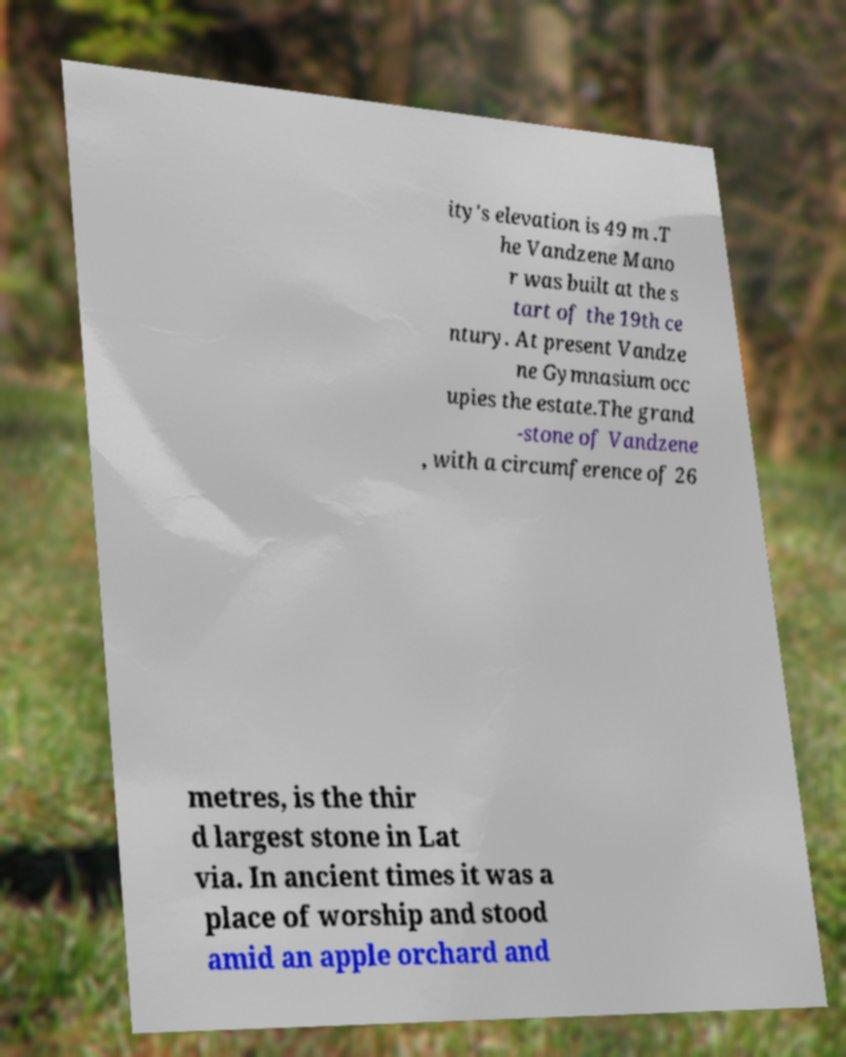For documentation purposes, I need the text within this image transcribed. Could you provide that? ity's elevation is 49 m .T he Vandzene Mano r was built at the s tart of the 19th ce ntury. At present Vandze ne Gymnasium occ upies the estate.The grand -stone of Vandzene , with a circumference of 26 metres, is the thir d largest stone in Lat via. In ancient times it was a place of worship and stood amid an apple orchard and 